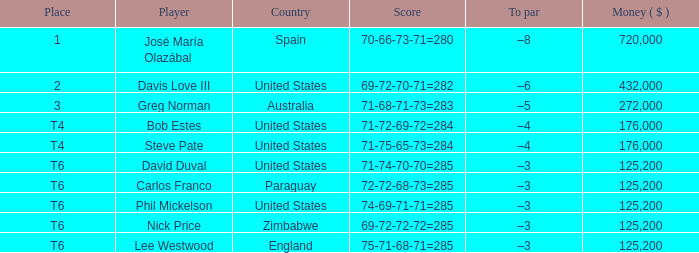Which Score has a Place of t6, and a Country of paraguay? 72-72-68-73=285. 